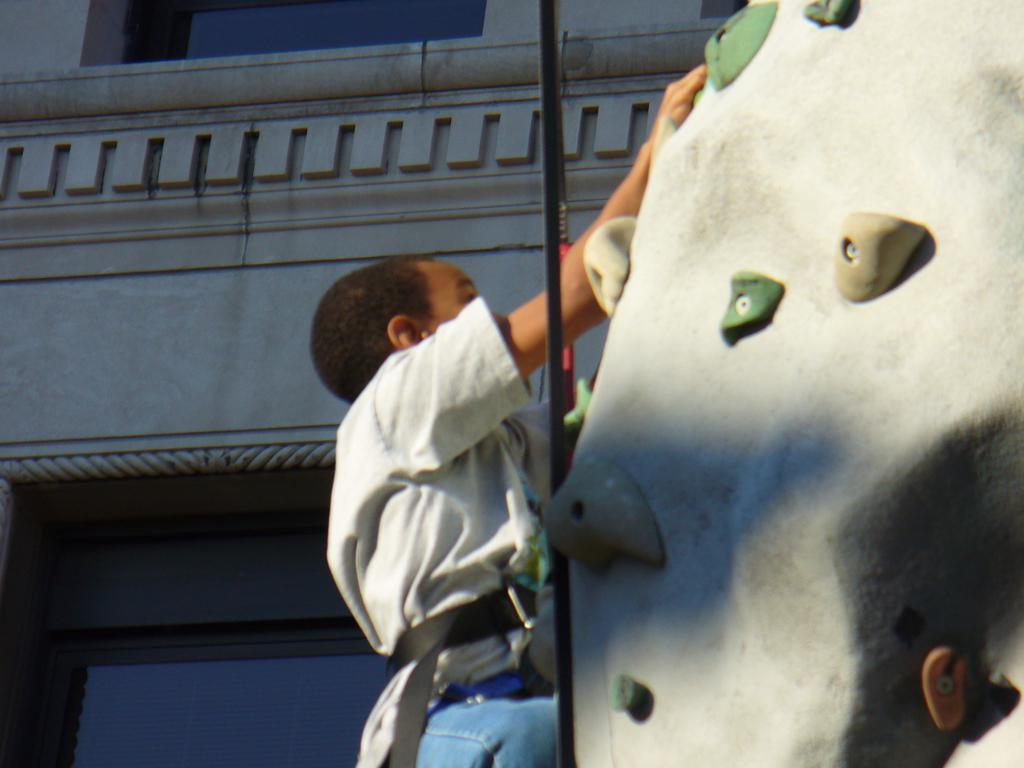What is located on the right side of the image? There is an artificial rock with resin molds on the right side of the image. What is the person in the image doing? A person is climbing on the rock. What can be seen behind the person in the image? There is a building with walls and glasses behind the person. How many pizzas are on the artificial rock in the image? There are no pizzas present in the image; it features an artificial rock with resin molds. What type of system is being used by the person to climb the rock in the image? There is no system visible in the image; the person is climbing the rock without any apparent assistance. 